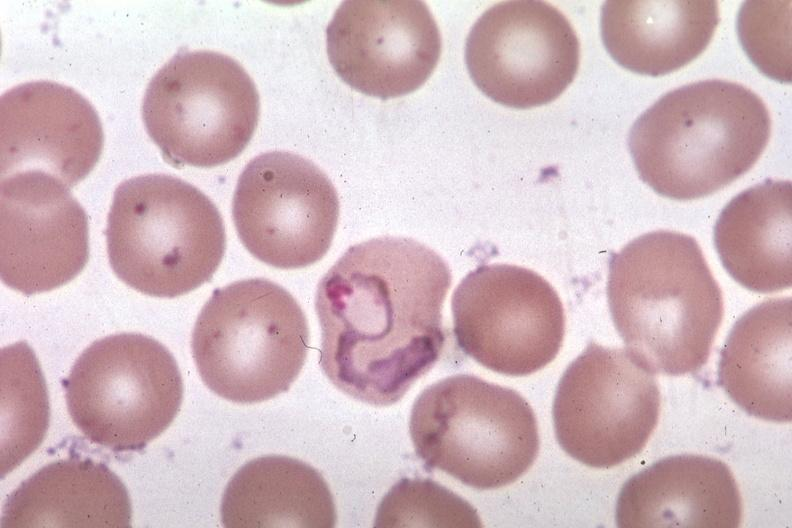does villous adenoma show oil wrights excellent tropho?
Answer the question using a single word or phrase. No 